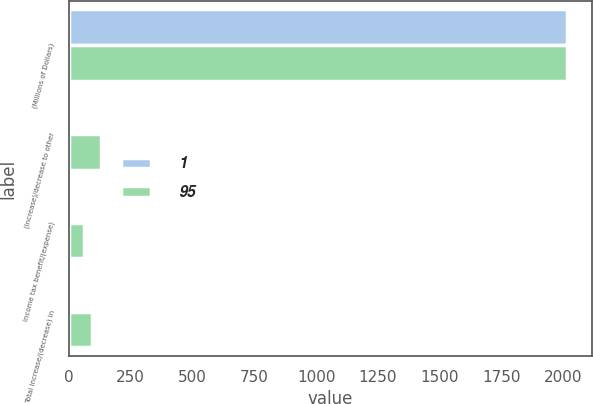Convert chart to OTSL. <chart><loc_0><loc_0><loc_500><loc_500><stacked_bar_chart><ecel><fcel>(Millions of Dollars)<fcel>(Increase)/decrease to other<fcel>Income tax benefit/(expense)<fcel>Total increase/(decrease) in<nl><fcel>1<fcel>2014<fcel>13<fcel>14<fcel>1<nl><fcel>95<fcel>2013<fcel>131<fcel>63<fcel>95<nl></chart> 